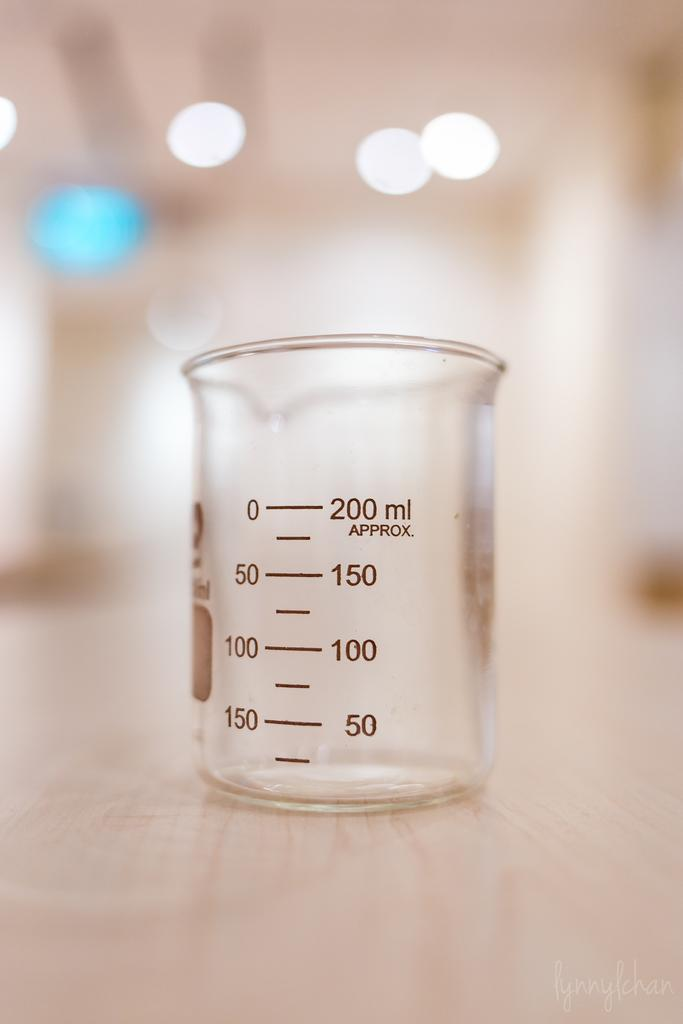What object is present in the image that is made of glass? There is a glass beaker in the image. What feature is present on the glass beaker? The glass beaker has numbers on it. What type of hat is the glass beaker wearing in the image? There is no hat present in the image, as the subject is a glass beaker. 